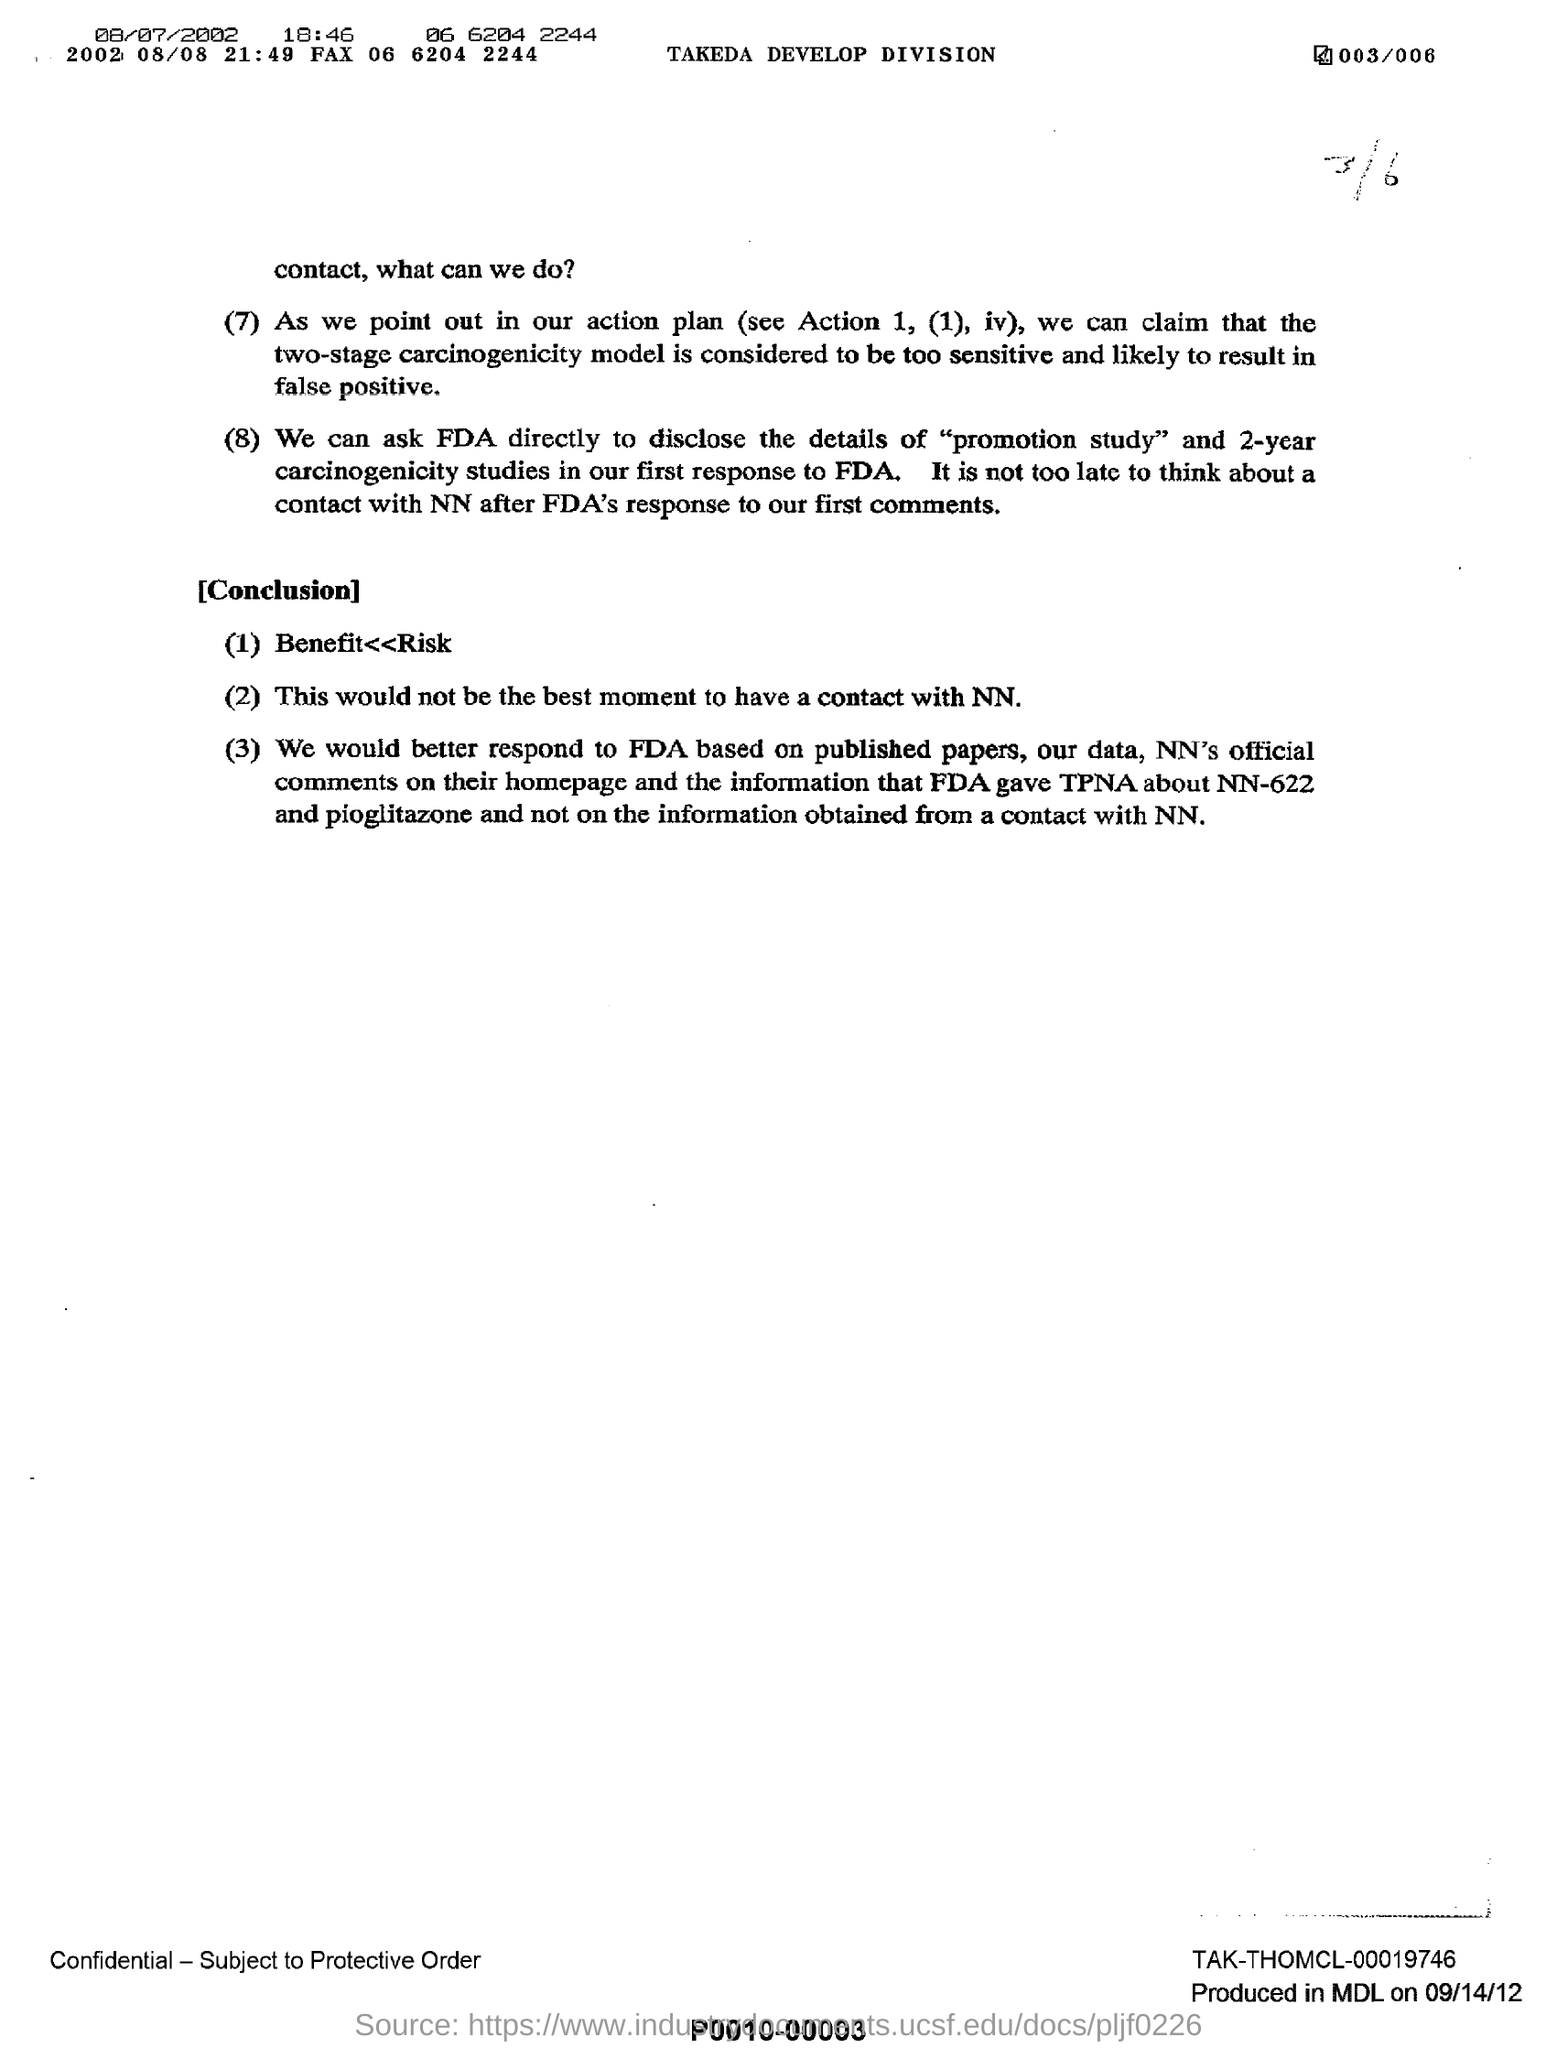Give some essential details in this illustration. The fax number is 06 6204 2244. The FDA is the entity to whom the students can directly ask for information regarding the promotion study. The Takeda Develop division is the name of the division. 